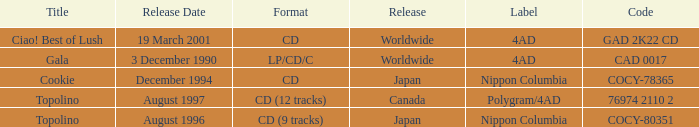What Label has a Code of cocy-78365? Nippon Columbia. 